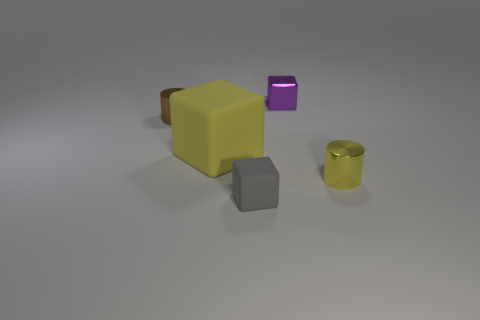What material is the yellow object left of the shiny cylinder on the right side of the tiny purple block made of? rubber 